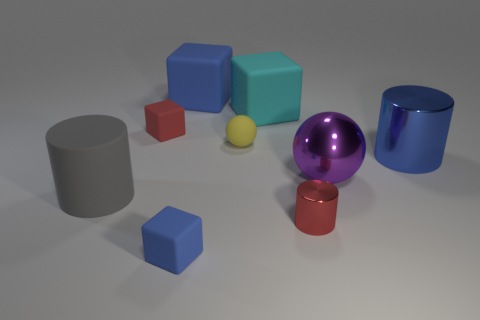What is the material of the large object that is both behind the metallic ball and right of the small red metal cylinder?
Provide a short and direct response. Metal. There is a cylinder that is the same size as the yellow rubber object; what is its color?
Provide a succinct answer. Red. Is the cyan object made of the same material as the red object in front of the blue cylinder?
Keep it short and to the point. No. What number of other objects are the same size as the blue cylinder?
Your answer should be very brief. 4. There is a blue matte thing that is in front of the large cyan rubber thing that is behind the red rubber object; is there a gray matte cylinder behind it?
Provide a succinct answer. Yes. What size is the yellow sphere?
Your response must be concise. Small. How big is the matte block to the left of the tiny blue object?
Give a very brief answer. Small. There is a blue matte thing that is behind the blue cylinder; is its size the same as the purple shiny thing?
Offer a terse response. Yes. Is there any other thing that has the same color as the small metallic cylinder?
Ensure brevity in your answer.  Yes. The red rubber object is what shape?
Your response must be concise. Cube. 